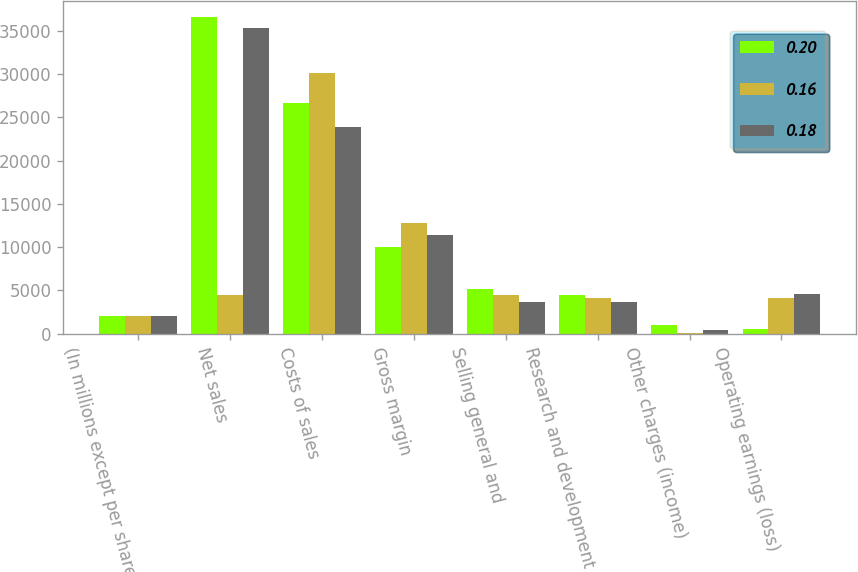Convert chart. <chart><loc_0><loc_0><loc_500><loc_500><stacked_bar_chart><ecel><fcel>(In millions except per share<fcel>Net sales<fcel>Costs of sales<fcel>Gross margin<fcel>Selling general and<fcel>Research and development<fcel>Other charges (income)<fcel>Operating earnings (loss)<nl><fcel>0.2<fcel>2007<fcel>36622<fcel>26670<fcel>9952<fcel>5092<fcel>4429<fcel>984<fcel>553<nl><fcel>0.16<fcel>2006<fcel>4429<fcel>30120<fcel>12727<fcel>4504<fcel>4106<fcel>25<fcel>4092<nl><fcel>0.18<fcel>2005<fcel>35310<fcel>23881<fcel>11429<fcel>3628<fcel>3600<fcel>404<fcel>4605<nl></chart> 